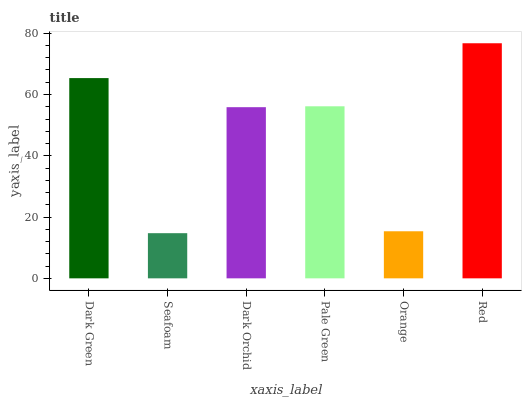Is Seafoam the minimum?
Answer yes or no. Yes. Is Red the maximum?
Answer yes or no. Yes. Is Dark Orchid the minimum?
Answer yes or no. No. Is Dark Orchid the maximum?
Answer yes or no. No. Is Dark Orchid greater than Seafoam?
Answer yes or no. Yes. Is Seafoam less than Dark Orchid?
Answer yes or no. Yes. Is Seafoam greater than Dark Orchid?
Answer yes or no. No. Is Dark Orchid less than Seafoam?
Answer yes or no. No. Is Pale Green the high median?
Answer yes or no. Yes. Is Dark Orchid the low median?
Answer yes or no. Yes. Is Dark Orchid the high median?
Answer yes or no. No. Is Seafoam the low median?
Answer yes or no. No. 